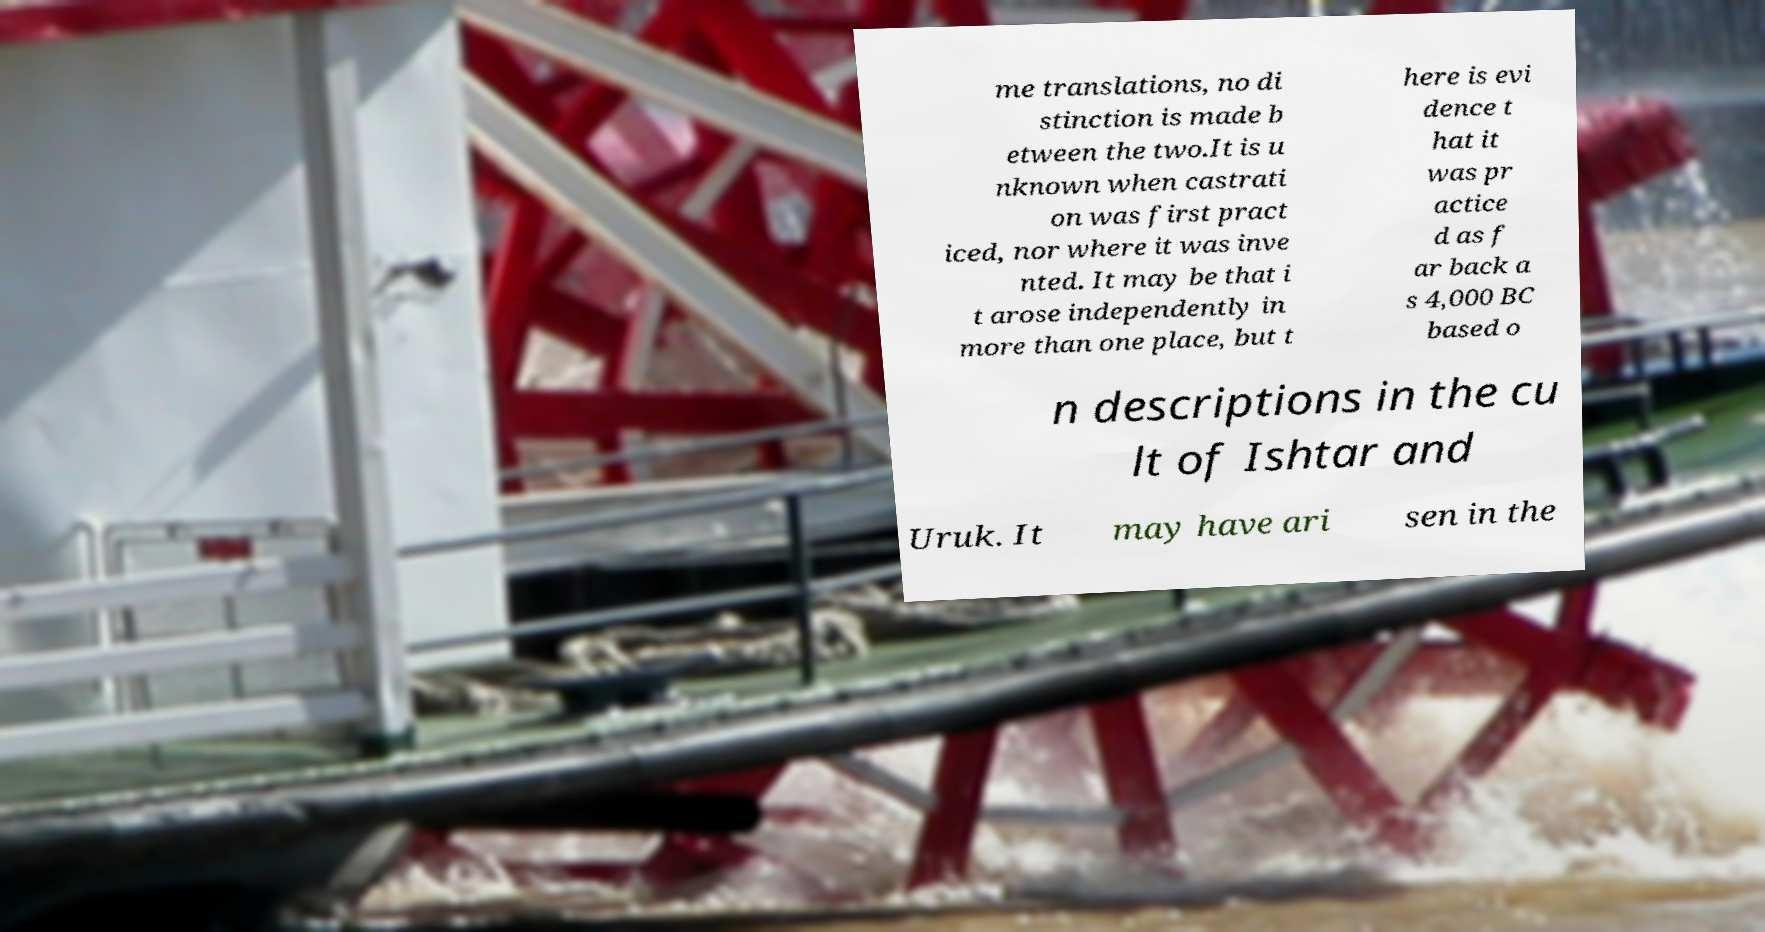Can you read and provide the text displayed in the image?This photo seems to have some interesting text. Can you extract and type it out for me? me translations, no di stinction is made b etween the two.It is u nknown when castrati on was first pract iced, nor where it was inve nted. It may be that i t arose independently in more than one place, but t here is evi dence t hat it was pr actice d as f ar back a s 4,000 BC based o n descriptions in the cu lt of Ishtar and Uruk. It may have ari sen in the 